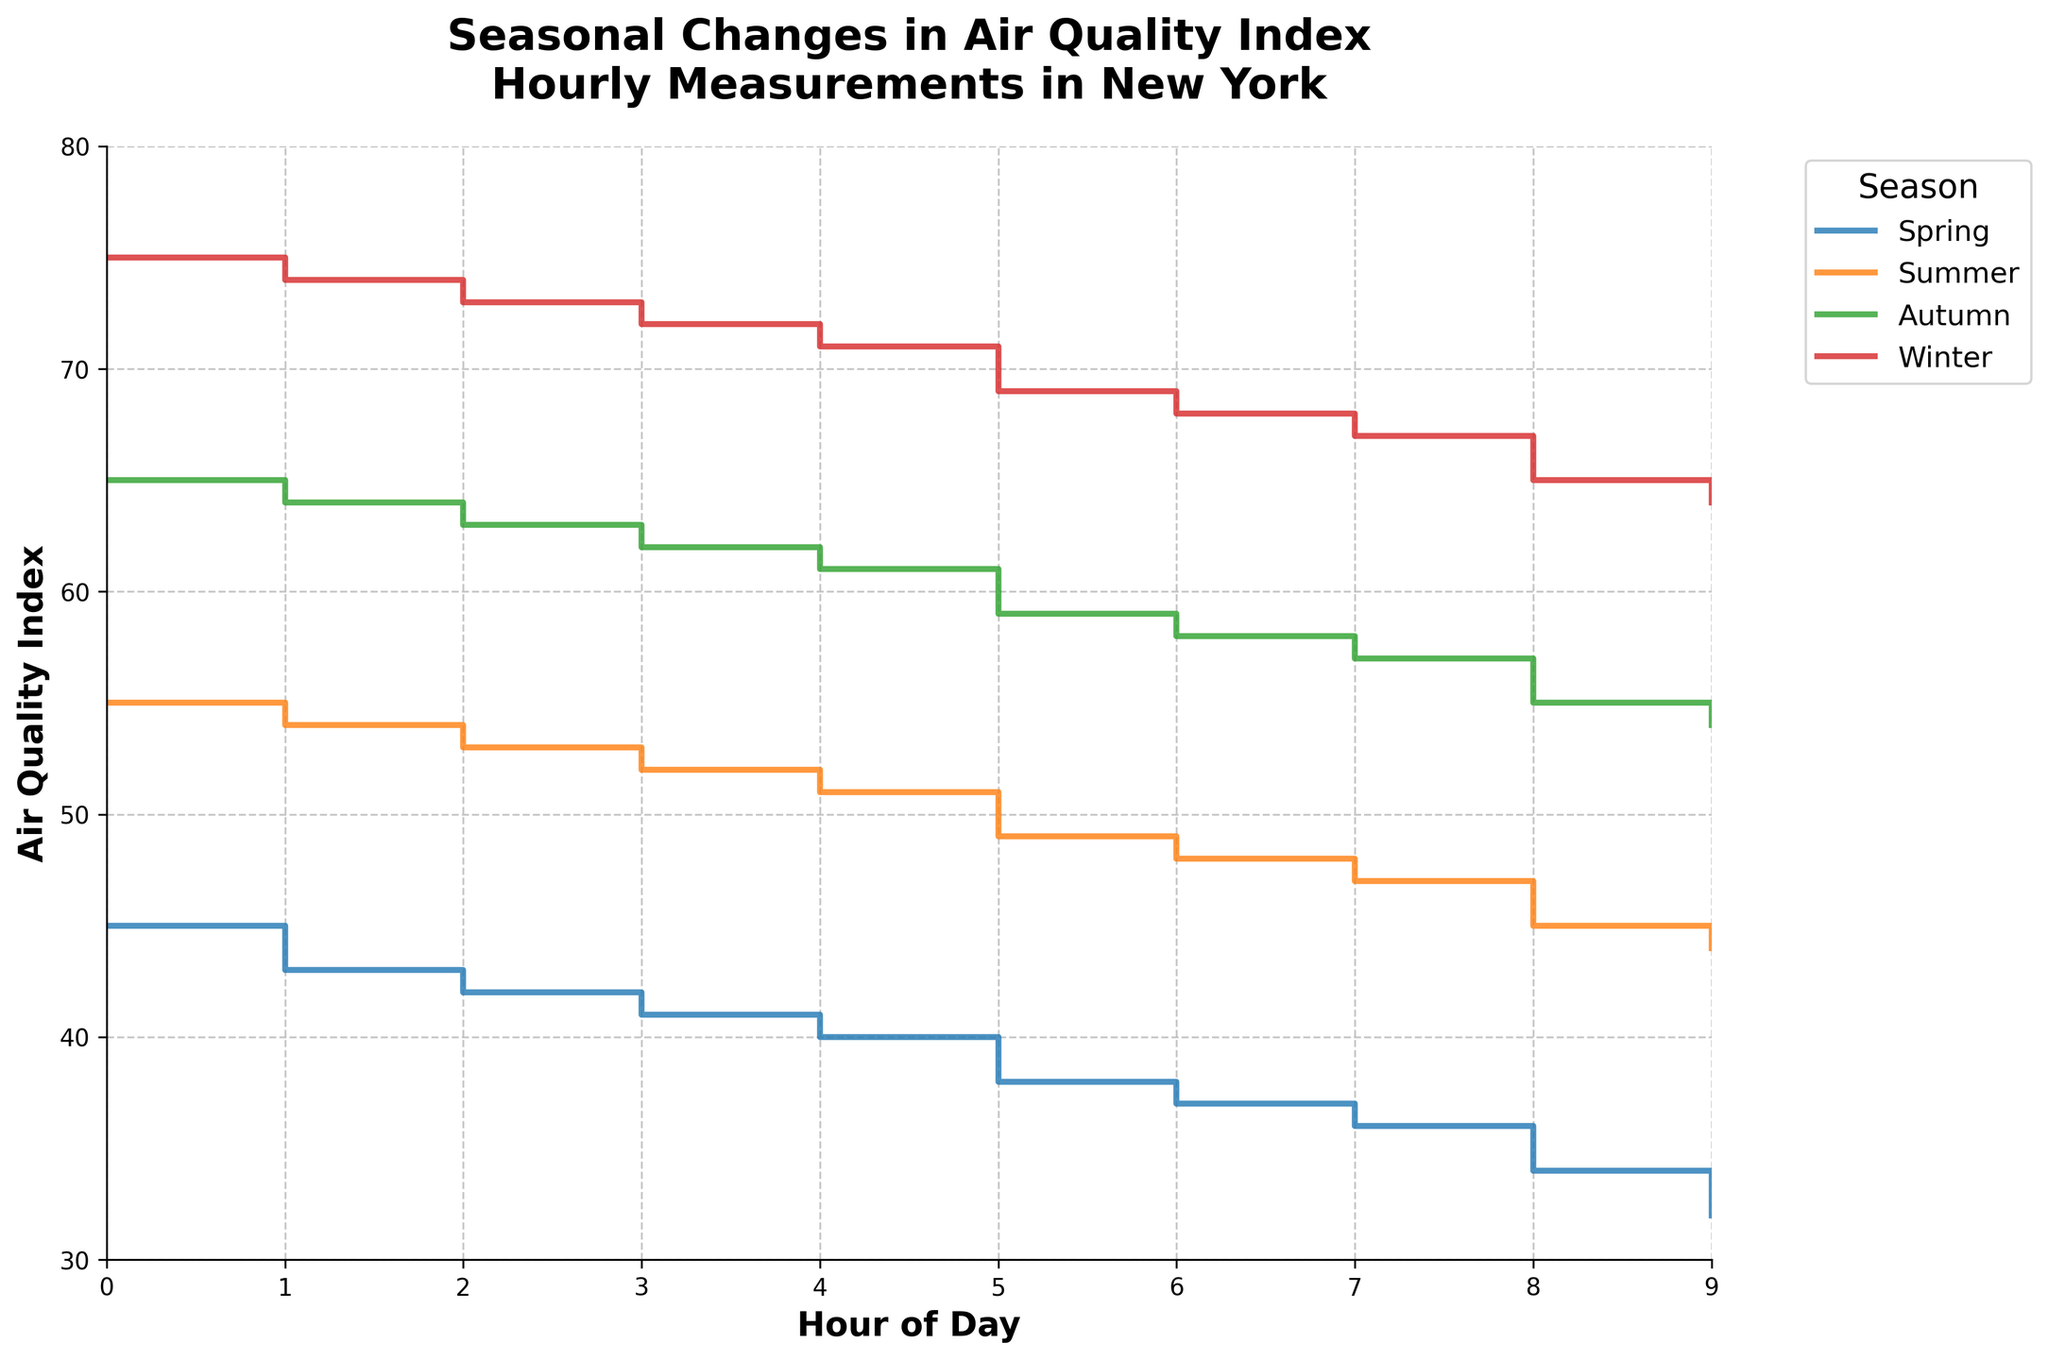How many seasons are represented in the plot? The plot divides the data into four distinct seasons, indicated by different colored lines and the legend titled 'Season'.
Answer: Four What season has the highest Air Quality Index values? The plot shows different trends in AQI across seasons. The Winter season, shown by the corresponding line, has the highest AQI values, reaching up to 75.
Answer: Winter What time of day does the Air Quality Index for Spring reach its lowest? By observing the Spring data line, it is clear that the lowest AQI value occurs at 9 am, reaching 32.
Answer: 9 am Compare the Air Quality Index ranges between Autumn and Winter. The AQI for Autumn ranges from 54 to 65, while the AQI for Winter ranges from 64 to 75. Comparing the ranges, Winter consistently has higher values than Autumn.
Answer: Winter has higher values At what hour do the Summer and Autumn Air Quality Index values cross, if at all? By examining the plot, it is noticeable that the Summer and Autumn lines cross at 8 am when both have an AQI value of 55.
Answer: 8 am Which season shows the steepest decline in Air Quality Index from the start to the end of the data? Observing the slopes of the lines, Winter shows the steepest decline from 75 to 64 over the 10-hour period, indicating the highest change.
Answer: Winter What is the Air Quality Index difference between 0 am and 9 am in Summer? The AQI for Summer starts at 55 at 0 am and decreases to 44 by 9 am. The difference is 55 - 44 = 11.
Answer: 11 Which season has the most stable Air Quality Index, showing the least variation over the hours? Summer has the smallest decline from 55 to 44, showing the flattest trend compared to other seasons, indicating it is the most stable.
Answer: Summer How does the Air Quality Index at 0 am compare across all seasons? At 0 am, the AQI values are 45 for Spring, 55 for Summer, 65 for Autumn, and 75 for Winter. Winter has the highest value, and Spring has the lowest.
Answer: Winter is highest, Spring is lowest What can be inferred about the general trend of air quality throughout a typical day for each season? All seasons show a general decline in AQI as the day progresses, indicating that air quality tends to improve slightly from 0 am to 9 am across all seasons. This is inferred by the slope of the step lines all trending downwards.
Answer: AQI declines as day progresses 